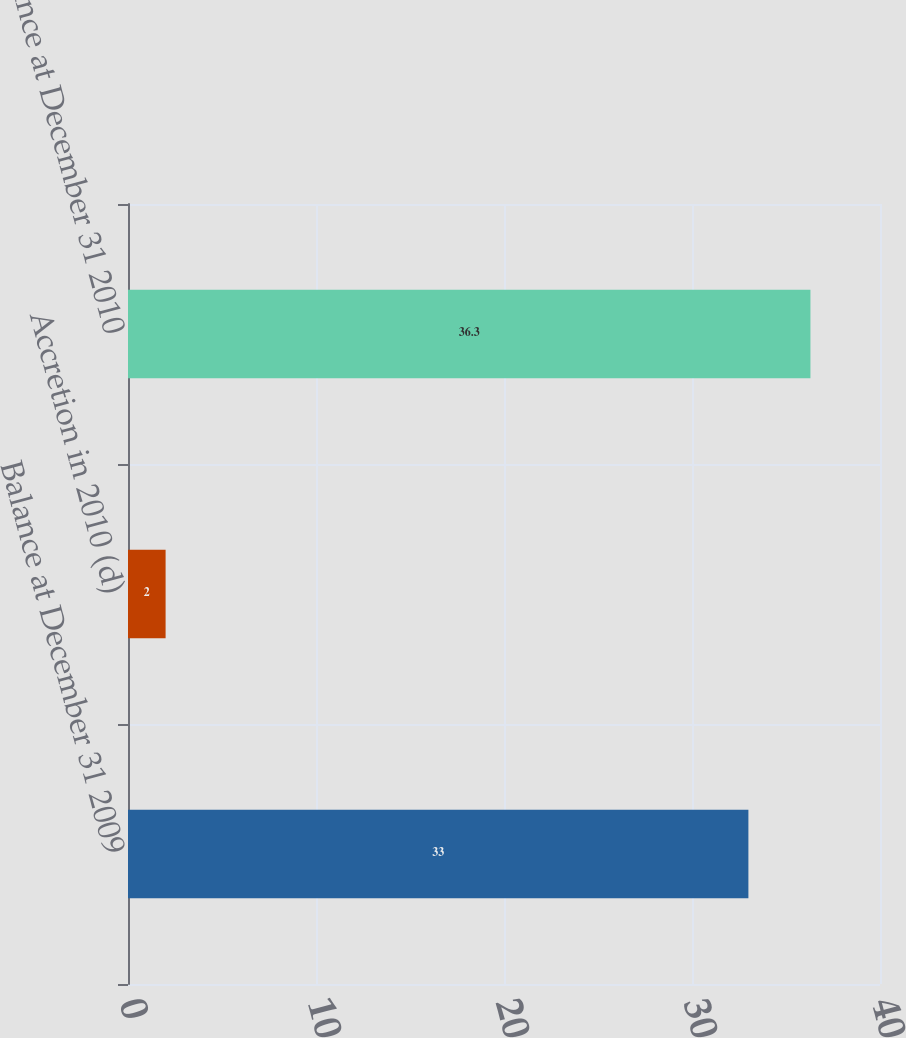Convert chart to OTSL. <chart><loc_0><loc_0><loc_500><loc_500><bar_chart><fcel>Balance at December 31 2009<fcel>Accretion in 2010 (d)<fcel>Balance at December 31 2010<nl><fcel>33<fcel>2<fcel>36.3<nl></chart> 